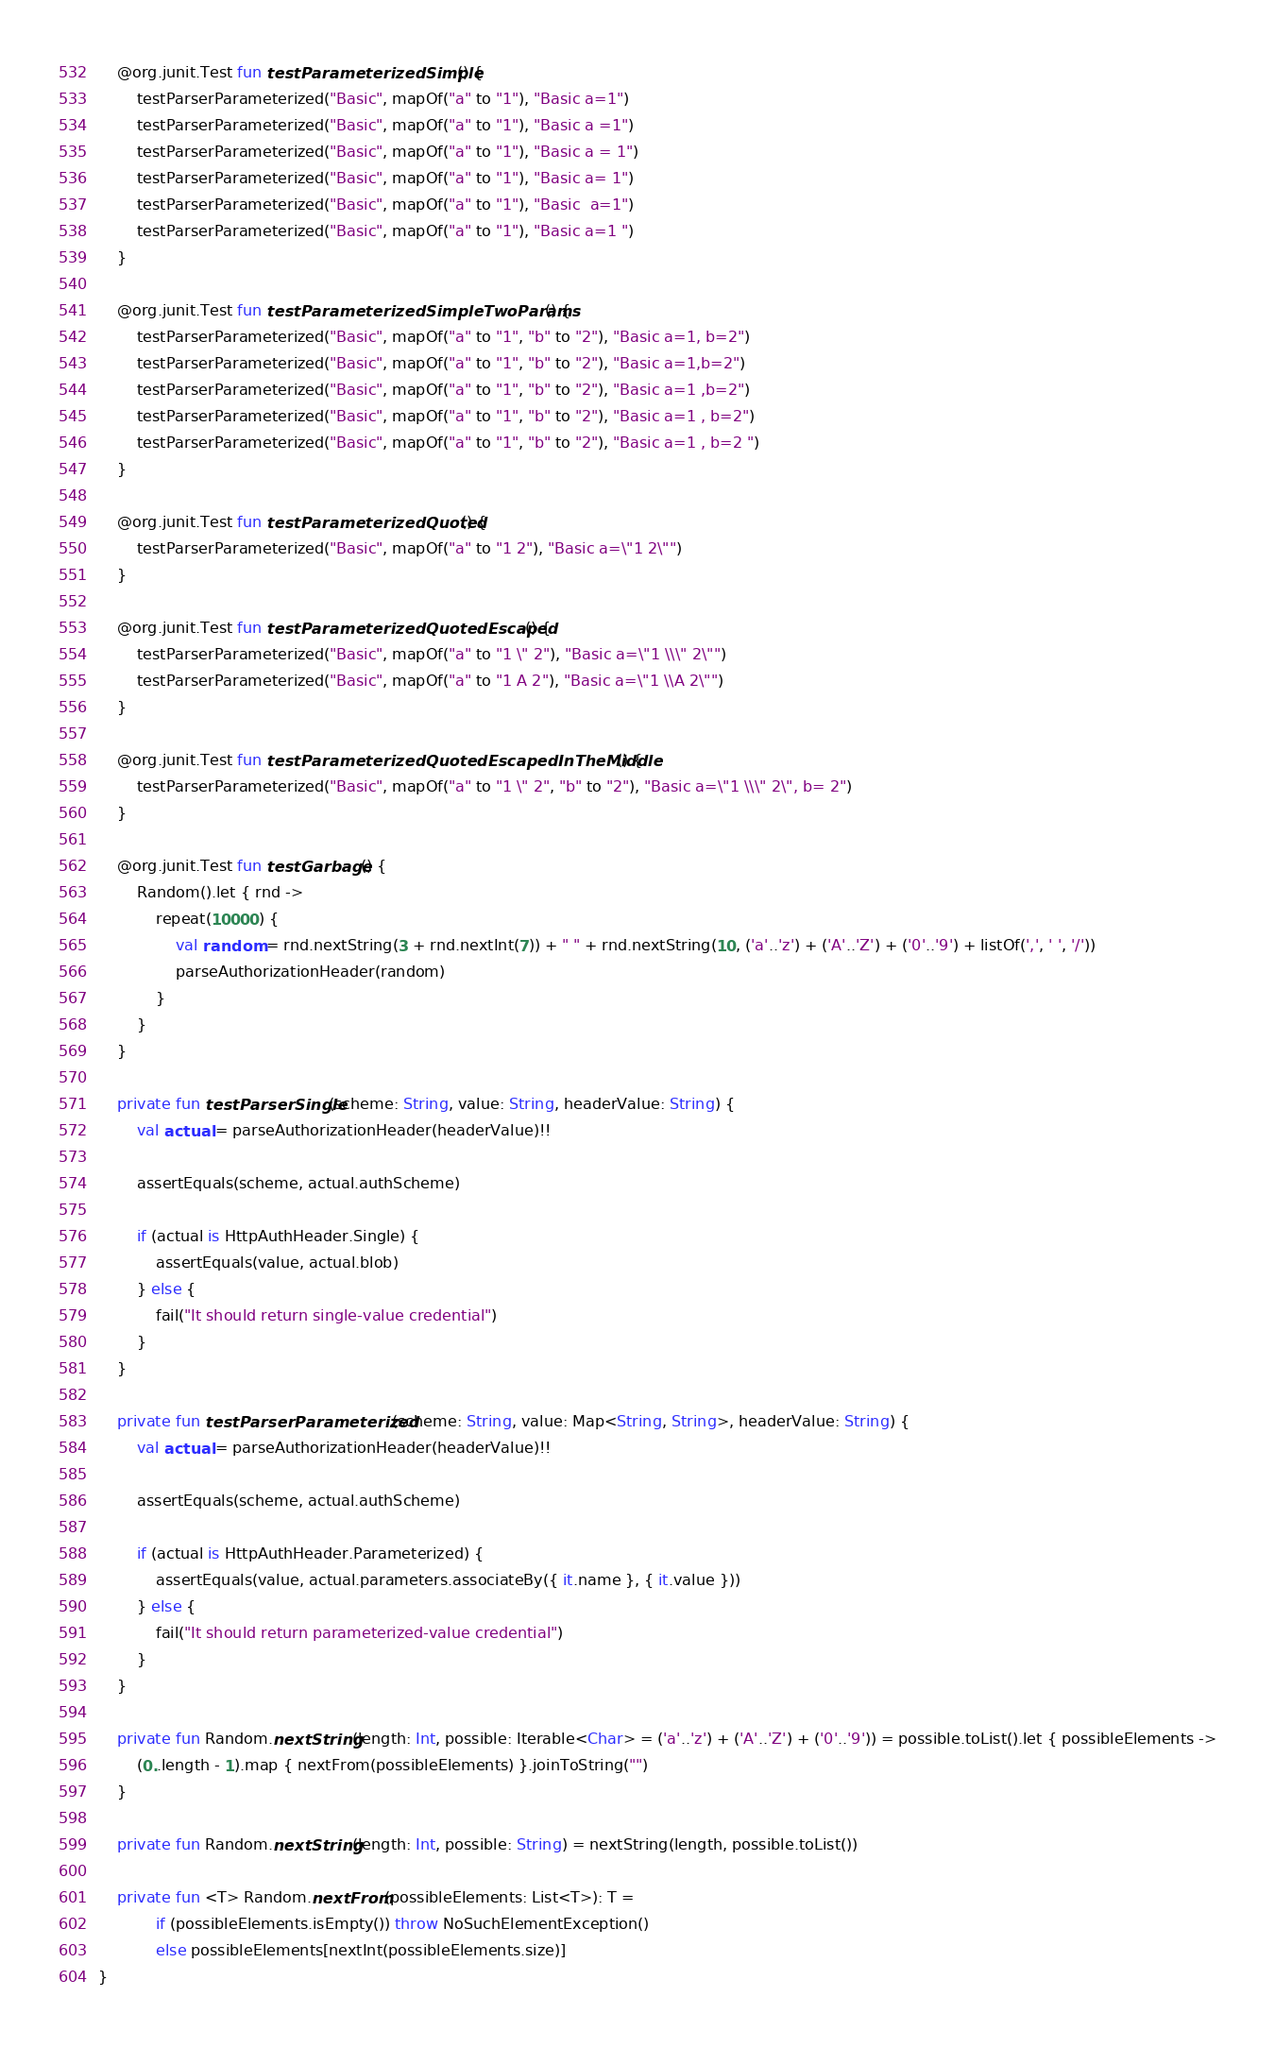<code> <loc_0><loc_0><loc_500><loc_500><_Kotlin_>    @org.junit.Test fun testParameterizedSimple() {
        testParserParameterized("Basic", mapOf("a" to "1"), "Basic a=1")
        testParserParameterized("Basic", mapOf("a" to "1"), "Basic a =1")
        testParserParameterized("Basic", mapOf("a" to "1"), "Basic a = 1")
        testParserParameterized("Basic", mapOf("a" to "1"), "Basic a= 1")
        testParserParameterized("Basic", mapOf("a" to "1"), "Basic  a=1")
        testParserParameterized("Basic", mapOf("a" to "1"), "Basic a=1 ")
    }

    @org.junit.Test fun testParameterizedSimpleTwoParams() {
        testParserParameterized("Basic", mapOf("a" to "1", "b" to "2"), "Basic a=1, b=2")
        testParserParameterized("Basic", mapOf("a" to "1", "b" to "2"), "Basic a=1,b=2")
        testParserParameterized("Basic", mapOf("a" to "1", "b" to "2"), "Basic a=1 ,b=2")
        testParserParameterized("Basic", mapOf("a" to "1", "b" to "2"), "Basic a=1 , b=2")
        testParserParameterized("Basic", mapOf("a" to "1", "b" to "2"), "Basic a=1 , b=2 ")
    }

    @org.junit.Test fun testParameterizedQuoted() {
        testParserParameterized("Basic", mapOf("a" to "1 2"), "Basic a=\"1 2\"")
    }

    @org.junit.Test fun testParameterizedQuotedEscaped() {
        testParserParameterized("Basic", mapOf("a" to "1 \" 2"), "Basic a=\"1 \\\" 2\"")
        testParserParameterized("Basic", mapOf("a" to "1 A 2"), "Basic a=\"1 \\A 2\"")
    }

    @org.junit.Test fun testParameterizedQuotedEscapedInTheMiddle() {
        testParserParameterized("Basic", mapOf("a" to "1 \" 2", "b" to "2"), "Basic a=\"1 \\\" 2\", b= 2")
    }

    @org.junit.Test fun testGarbage() {
        Random().let { rnd ->
            repeat(10000) {
                val random = rnd.nextString(3 + rnd.nextInt(7)) + " " + rnd.nextString(10, ('a'..'z') + ('A'..'Z') + ('0'..'9') + listOf(',', ' ', '/'))
                parseAuthorizationHeader(random)
            }
        }
    }

    private fun testParserSingle(scheme: String, value: String, headerValue: String) {
        val actual = parseAuthorizationHeader(headerValue)!!

        assertEquals(scheme, actual.authScheme)

        if (actual is HttpAuthHeader.Single) {
            assertEquals(value, actual.blob)
        } else {
            fail("It should return single-value credential")
        }
    }

    private fun testParserParameterized(scheme: String, value: Map<String, String>, headerValue: String) {
        val actual = parseAuthorizationHeader(headerValue)!!

        assertEquals(scheme, actual.authScheme)

        if (actual is HttpAuthHeader.Parameterized) {
            assertEquals(value, actual.parameters.associateBy({ it.name }, { it.value }))
        } else {
            fail("It should return parameterized-value credential")
        }
    }

    private fun Random.nextString(length: Int, possible: Iterable<Char> = ('a'..'z') + ('A'..'Z') + ('0'..'9')) = possible.toList().let { possibleElements ->
        (0..length - 1).map { nextFrom(possibleElements) }.joinToString("")
    }

    private fun Random.nextString(length: Int, possible: String) = nextString(length, possible.toList())

    private fun <T> Random.nextFrom(possibleElements: List<T>): T =
            if (possibleElements.isEmpty()) throw NoSuchElementException()
            else possibleElements[nextInt(possibleElements.size)]
}
</code> 